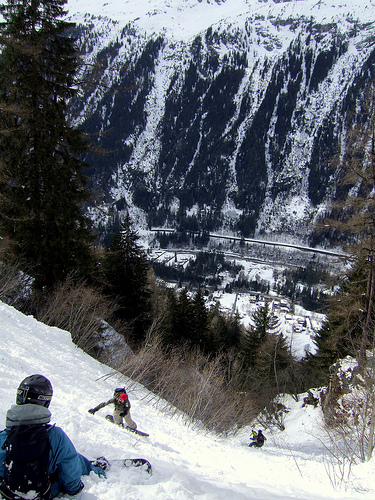<image>
Is the person to the left of the tree? No. The person is not to the left of the tree. From this viewpoint, they have a different horizontal relationship. 